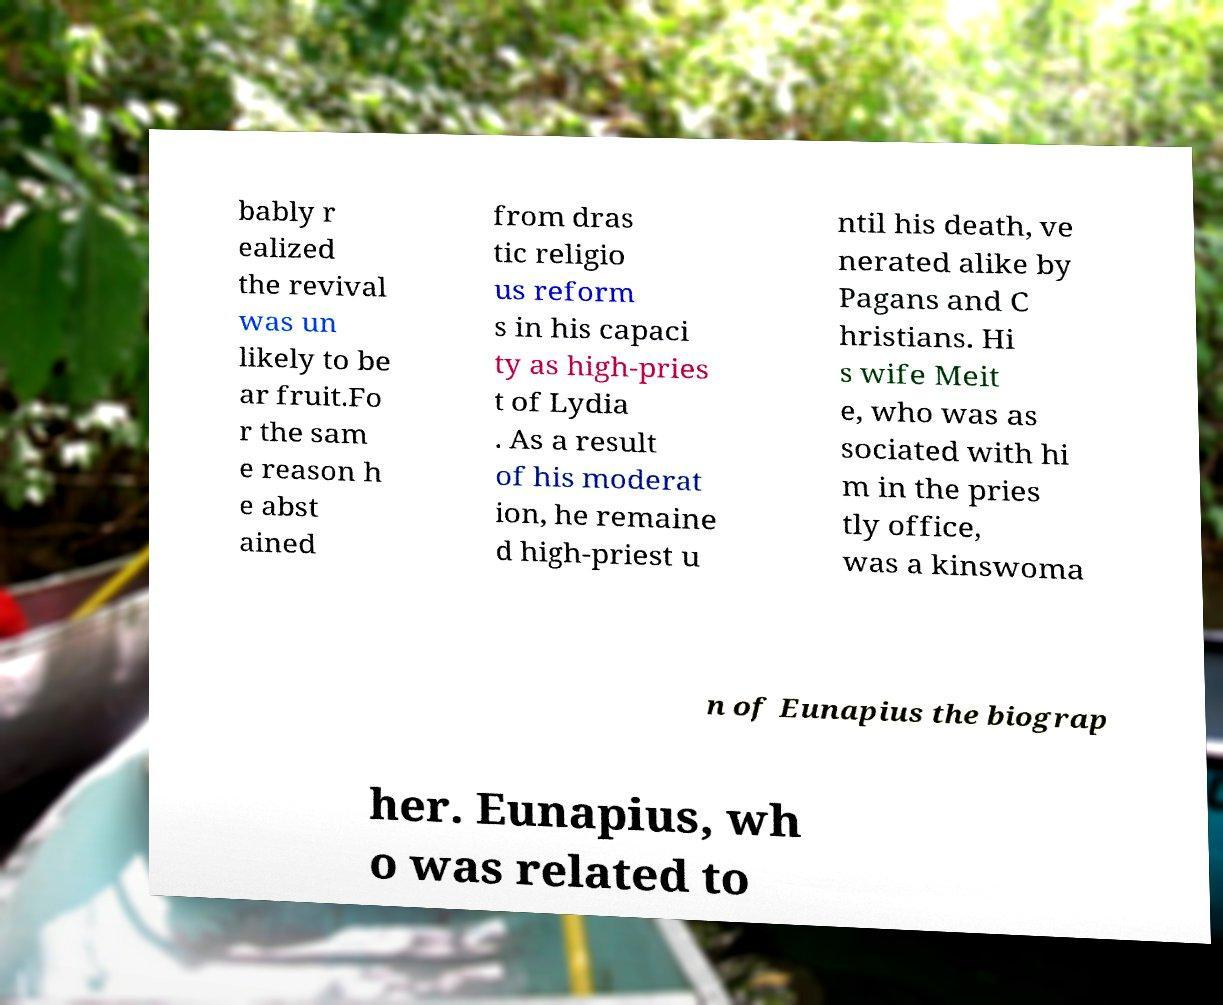For documentation purposes, I need the text within this image transcribed. Could you provide that? bably r ealized the revival was un likely to be ar fruit.Fo r the sam e reason h e abst ained from dras tic religio us reform s in his capaci ty as high-pries t of Lydia . As a result of his moderat ion, he remaine d high-priest u ntil his death, ve nerated alike by Pagans and C hristians. Hi s wife Meit e, who was as sociated with hi m in the pries tly office, was a kinswoma n of Eunapius the biograp her. Eunapius, wh o was related to 